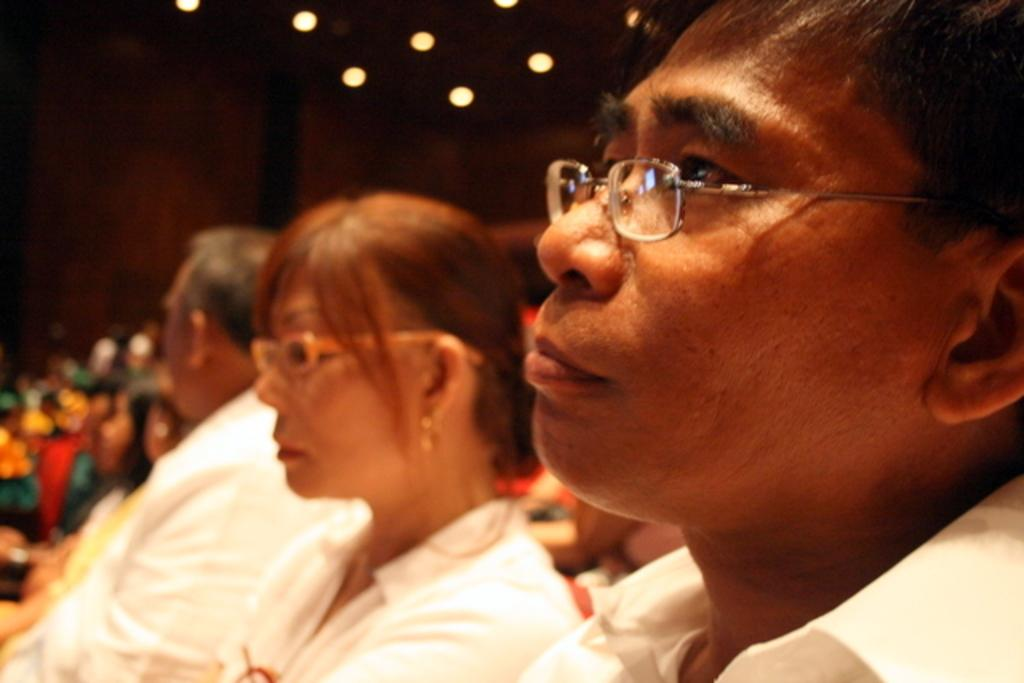What are the people in the image doing? The people in the image are sitting. What can be seen on the roof in the image? There are lights visible on the roof in the image. What type of breath can be seen coming from the people in the image? There is no visible breath coming from the people in the image. What language are the people in the image speaking? The image does not provide any information about the language being spoken by the people. 